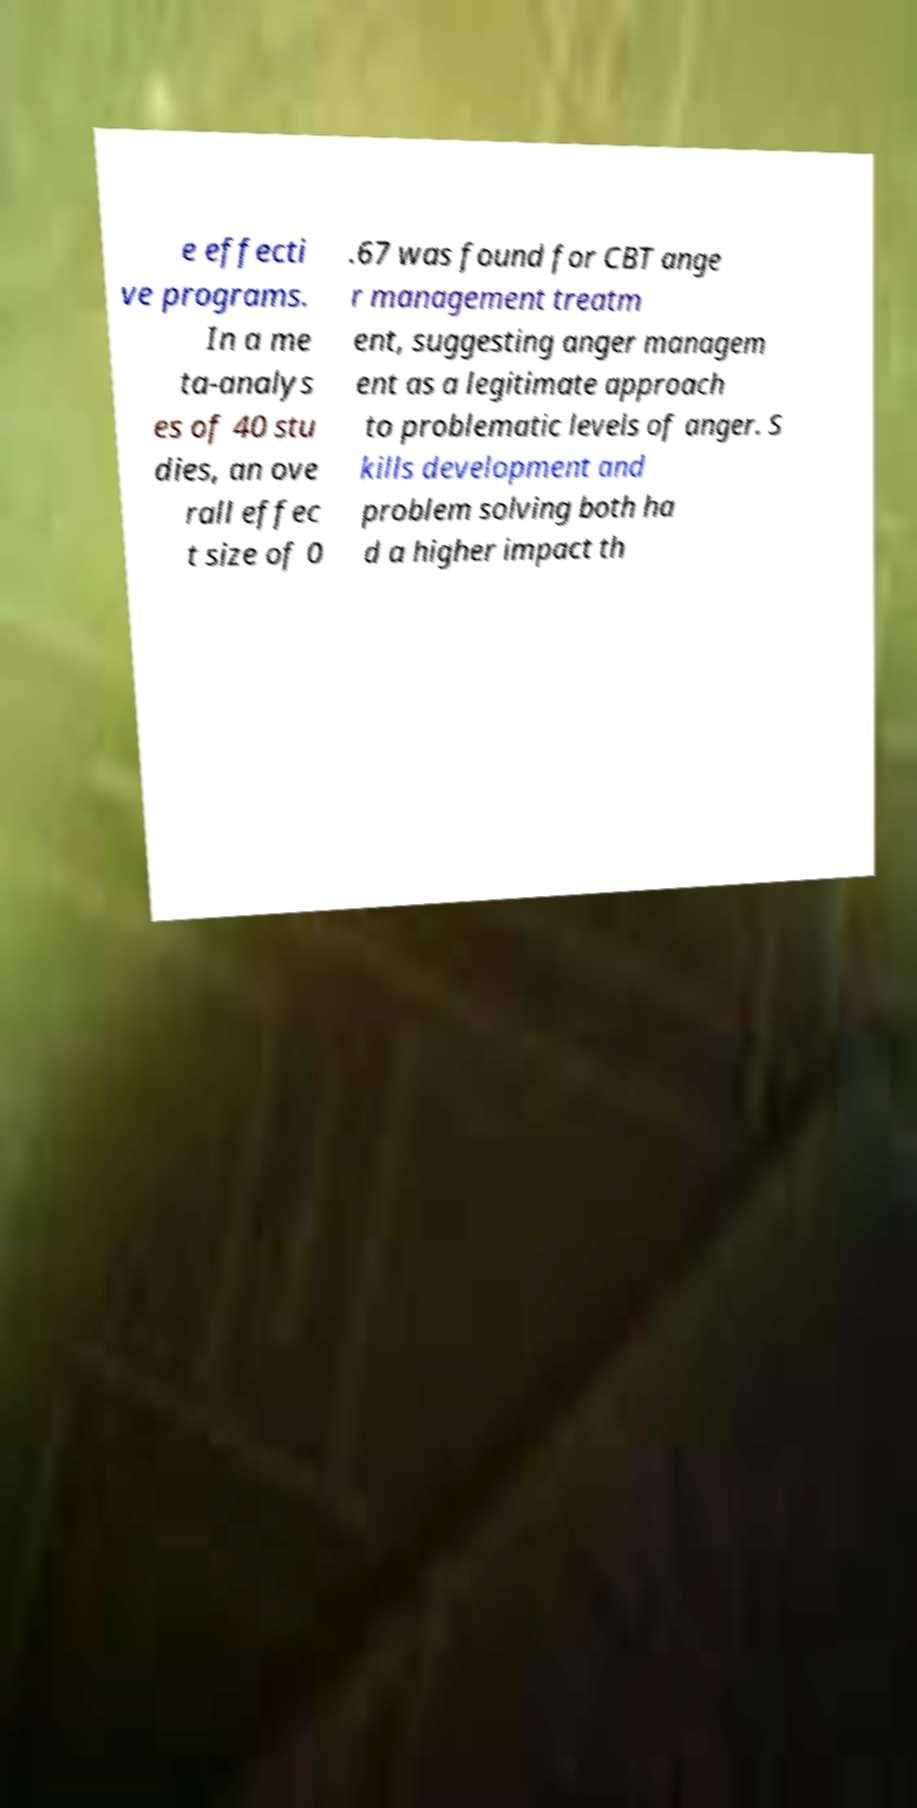I need the written content from this picture converted into text. Can you do that? e effecti ve programs. In a me ta-analys es of 40 stu dies, an ove rall effec t size of 0 .67 was found for CBT ange r management treatm ent, suggesting anger managem ent as a legitimate approach to problematic levels of anger. S kills development and problem solving both ha d a higher impact th 